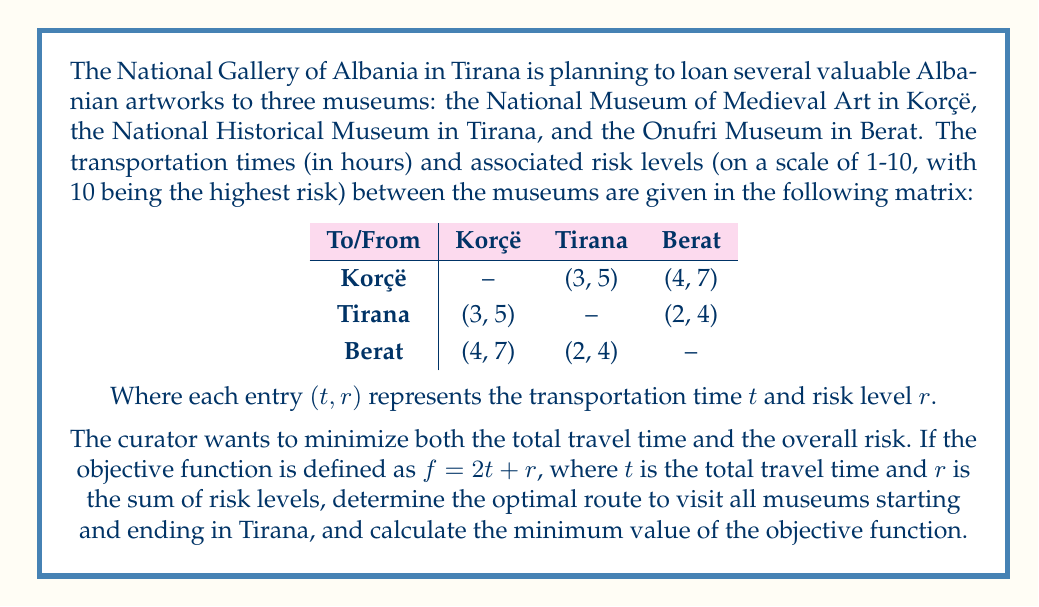Give your solution to this math problem. To solve this problem, we need to consider all possible routes starting and ending in Tirana that visit all museums. Then, we'll calculate the objective function value for each route and choose the one with the minimum value.

Possible routes:
1. Tirana → Korçë → Berat → Tirana
2. Tirana → Berat → Korçë → Tirana

Let's calculate the objective function value for each route:

Route 1: Tirana → Korçë → Berat → Tirana
- Travel time: 3 + 4 + 2 = 9 hours
- Risk levels: 5 + 7 + 4 = 16
- Objective function: $f = 2t + r = 2(9) + 16 = 34$

Route 2: Tirana → Berat → Korçë → Tirana
- Travel time: 2 + 4 + 3 = 9 hours
- Risk levels: 4 + 7 + 5 = 16
- Objective function: $f = 2t + r = 2(9) + 16 = 34$

Both routes have the same objective function value, which means they are both optimal solutions. The curator can choose either route based on other factors not considered in the objective function.

The minimum value of the objective function is 34.
Answer: The optimal routes are:
1. Tirana → Korçë → Berat → Tirana
2. Tirana → Berat → Korçë → Tirana

The minimum value of the objective function is 34. 